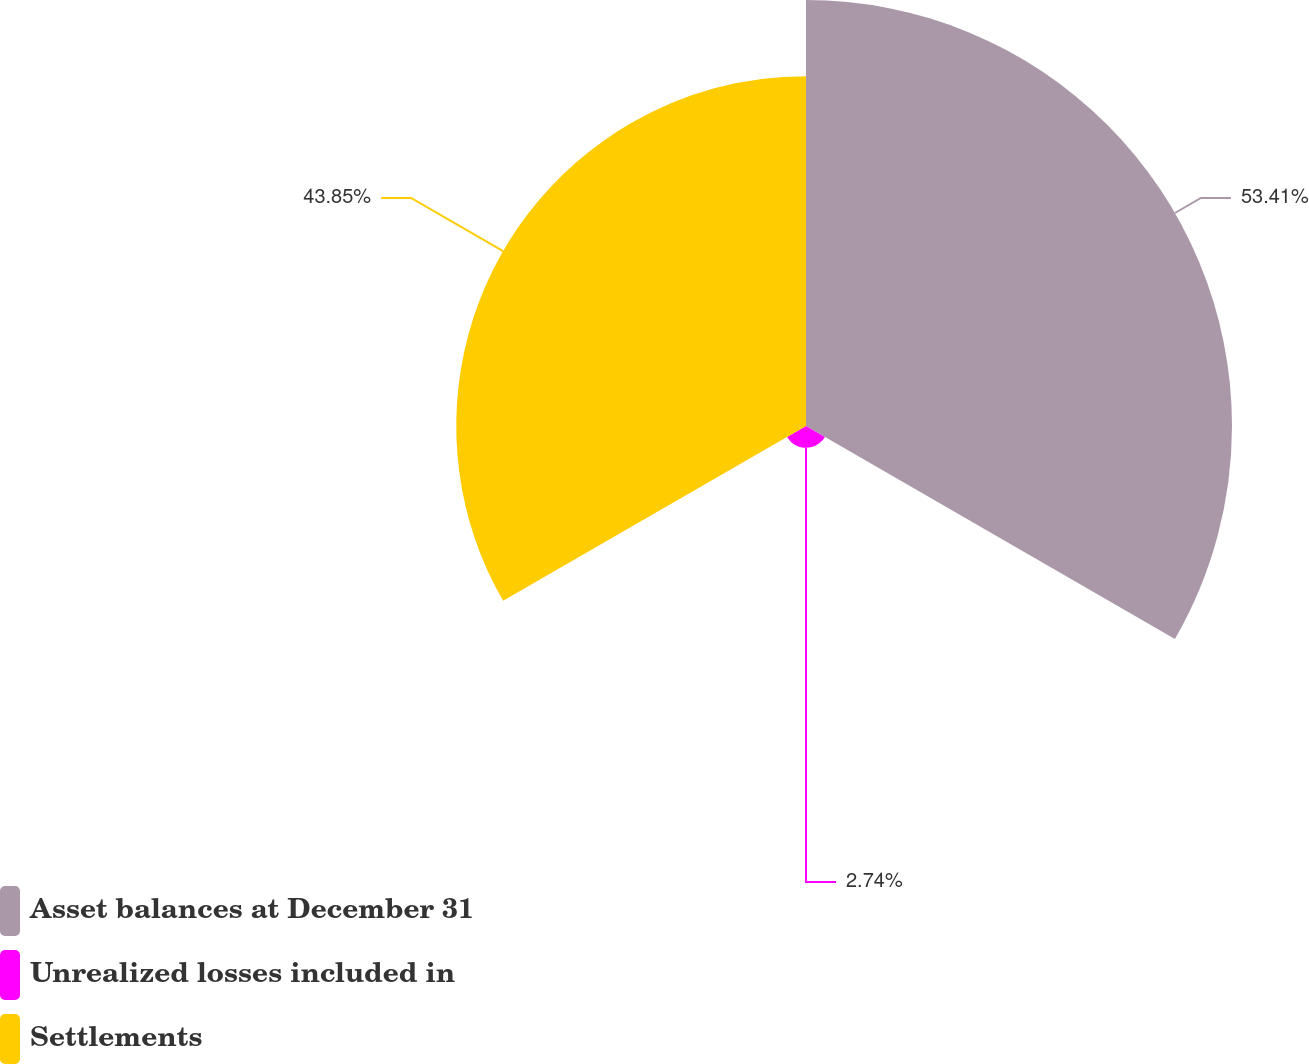Convert chart. <chart><loc_0><loc_0><loc_500><loc_500><pie_chart><fcel>Asset balances at December 31<fcel>Unrealized losses included in<fcel>Settlements<nl><fcel>53.41%<fcel>2.74%<fcel>43.85%<nl></chart> 